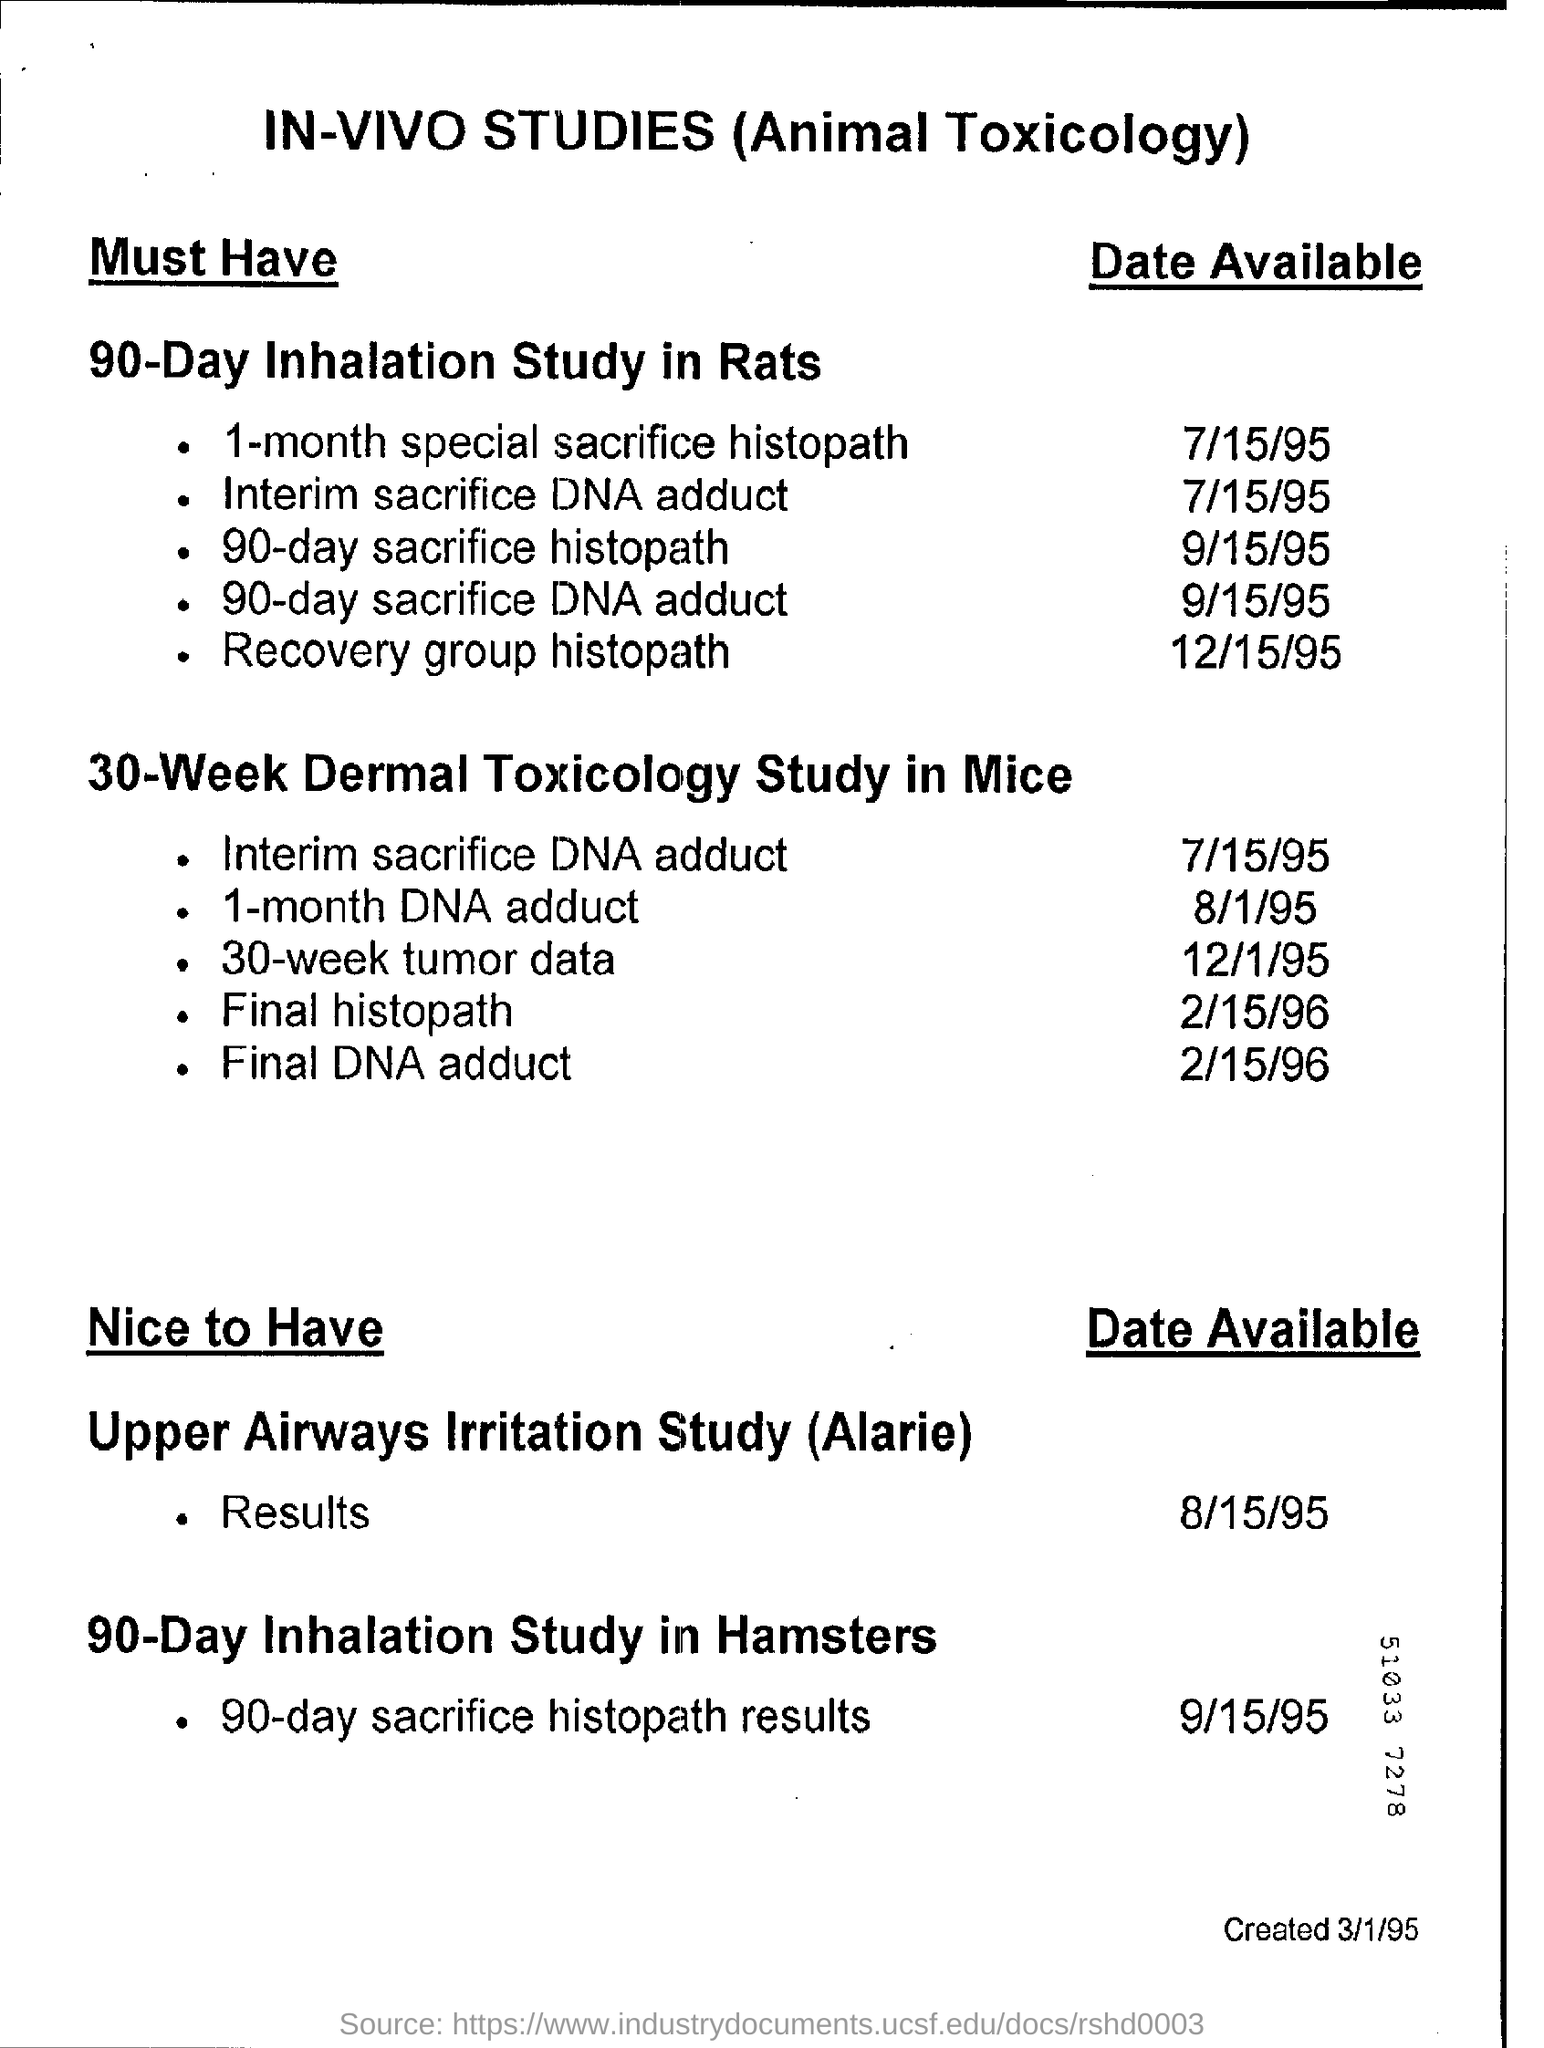Mention a couple of crucial points in this snapshot. The date available for the 1-month special sacrifice histopath is July 15th, 1995. The heading at the top of the page is "In-vivo studies (animal toxicology)". 